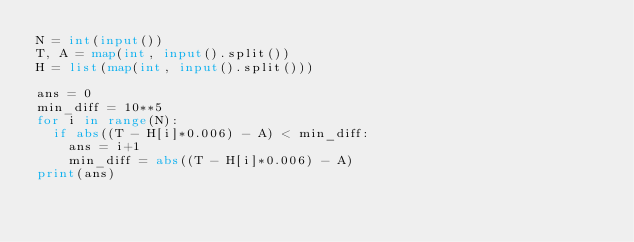Convert code to text. <code><loc_0><loc_0><loc_500><loc_500><_Python_>N = int(input())
T, A = map(int, input().split())
H = list(map(int, input().split()))

ans = 0
min_diff = 10**5
for i in range(N):
  if abs((T - H[i]*0.006) - A) < min_diff:
    ans = i+1
    min_diff = abs((T - H[i]*0.006) - A)
print(ans)
</code> 